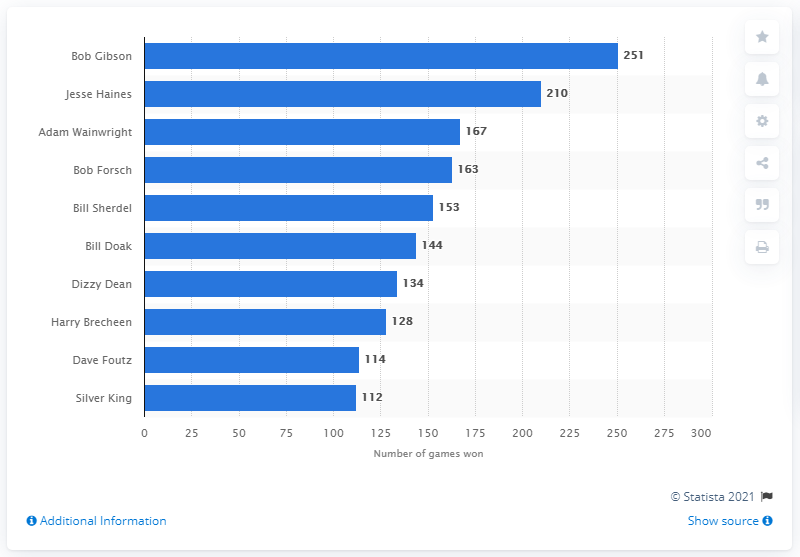Highlight a few significant elements in this photo. Bob Gibson has achieved the impressive feat of winning the most games in St. Louis Cardinals history with a total of 251 victories. The St. Louis Cardinals franchise has a history of outstanding athletes, but one player stands out as the winner of the most games: Bob Gibson. 